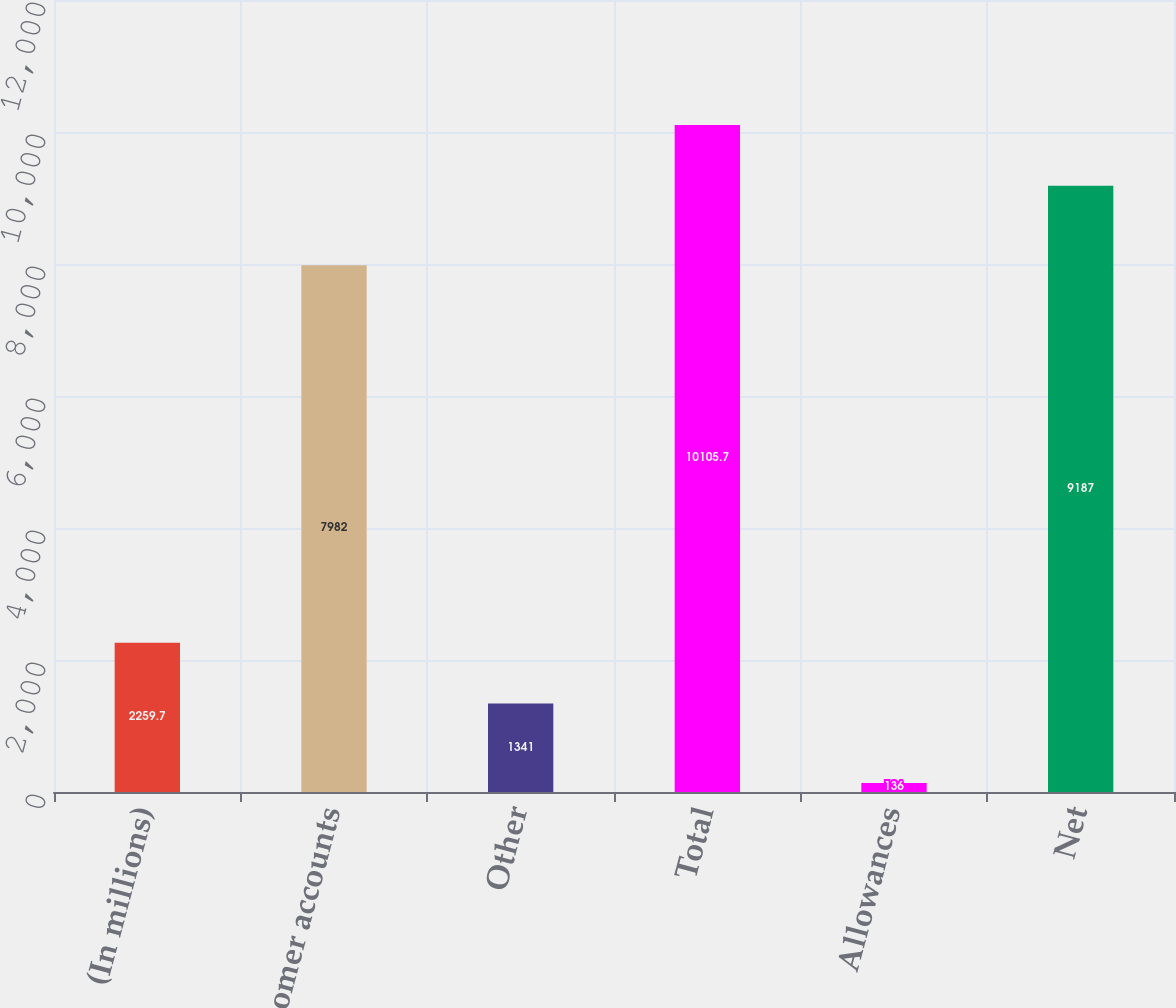Convert chart. <chart><loc_0><loc_0><loc_500><loc_500><bar_chart><fcel>(In millions)<fcel>Customer accounts<fcel>Other<fcel>Total<fcel>Allowances<fcel>Net<nl><fcel>2259.7<fcel>7982<fcel>1341<fcel>10105.7<fcel>136<fcel>9187<nl></chart> 